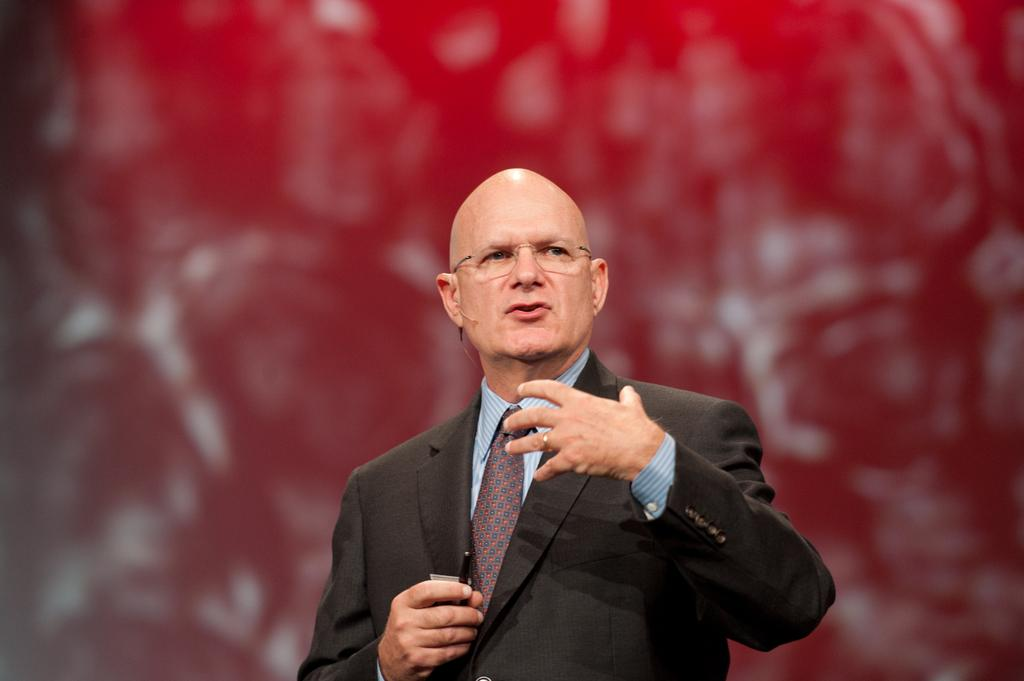What is the main subject of the image? There is a person standing in the center of the image. What can be observed about the person's appearance? The person is wearing spectacles. What is visible in the background of the image? There is a wall in the background of the image. What type of leather is being turned into a page in the image? There is no leather or pages present in the image; it features a person standing in front of a wall. 